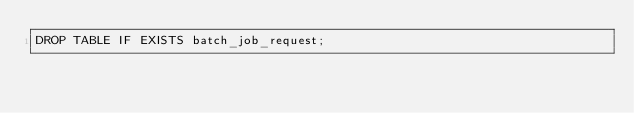Convert code to text. <code><loc_0><loc_0><loc_500><loc_500><_SQL_>DROP TABLE IF EXISTS batch_job_request;
</code> 